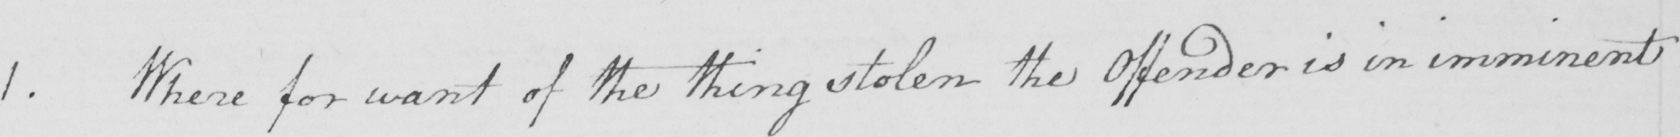Can you tell me what this handwritten text says? 1 . Where for want of the thing stolen the offender is in imminent 